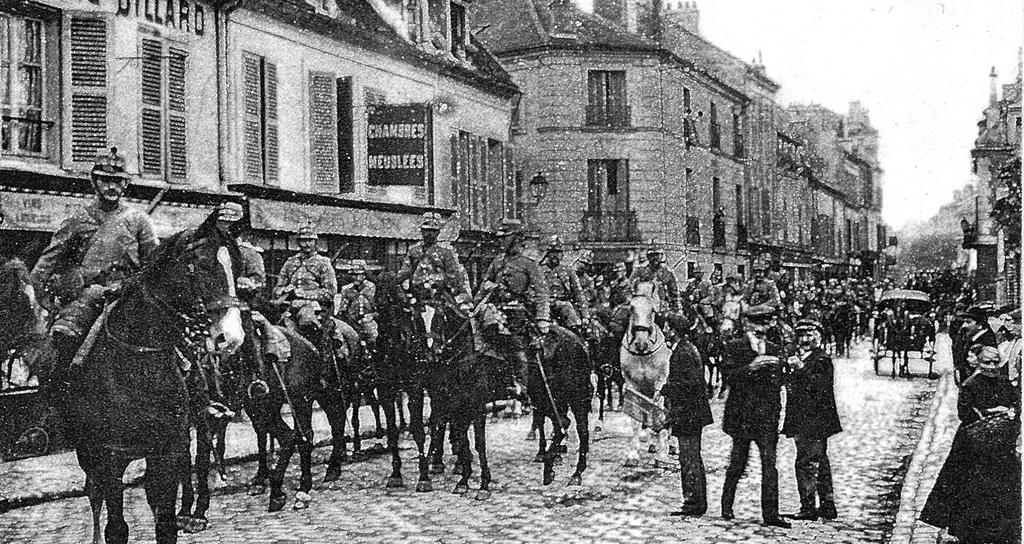What are the people doing in the image? The people are sitting on horses in the image. What can be seen in the background of the image? There are buildings near the people on horses. Where are the people on horses located? The people are on a road. Are there any other people in the image besides those on horses? Yes, some people are standing away from the people on horses. What type of trees are growing on the plot of land where the people are standing? There is no mention of trees or a plot of land in the image; it only shows people sitting on horses and standing nearby. 